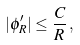Convert formula to latex. <formula><loc_0><loc_0><loc_500><loc_500>| \phi ^ { \prime } _ { R } | \leq \frac { C } { R } \, ,</formula> 